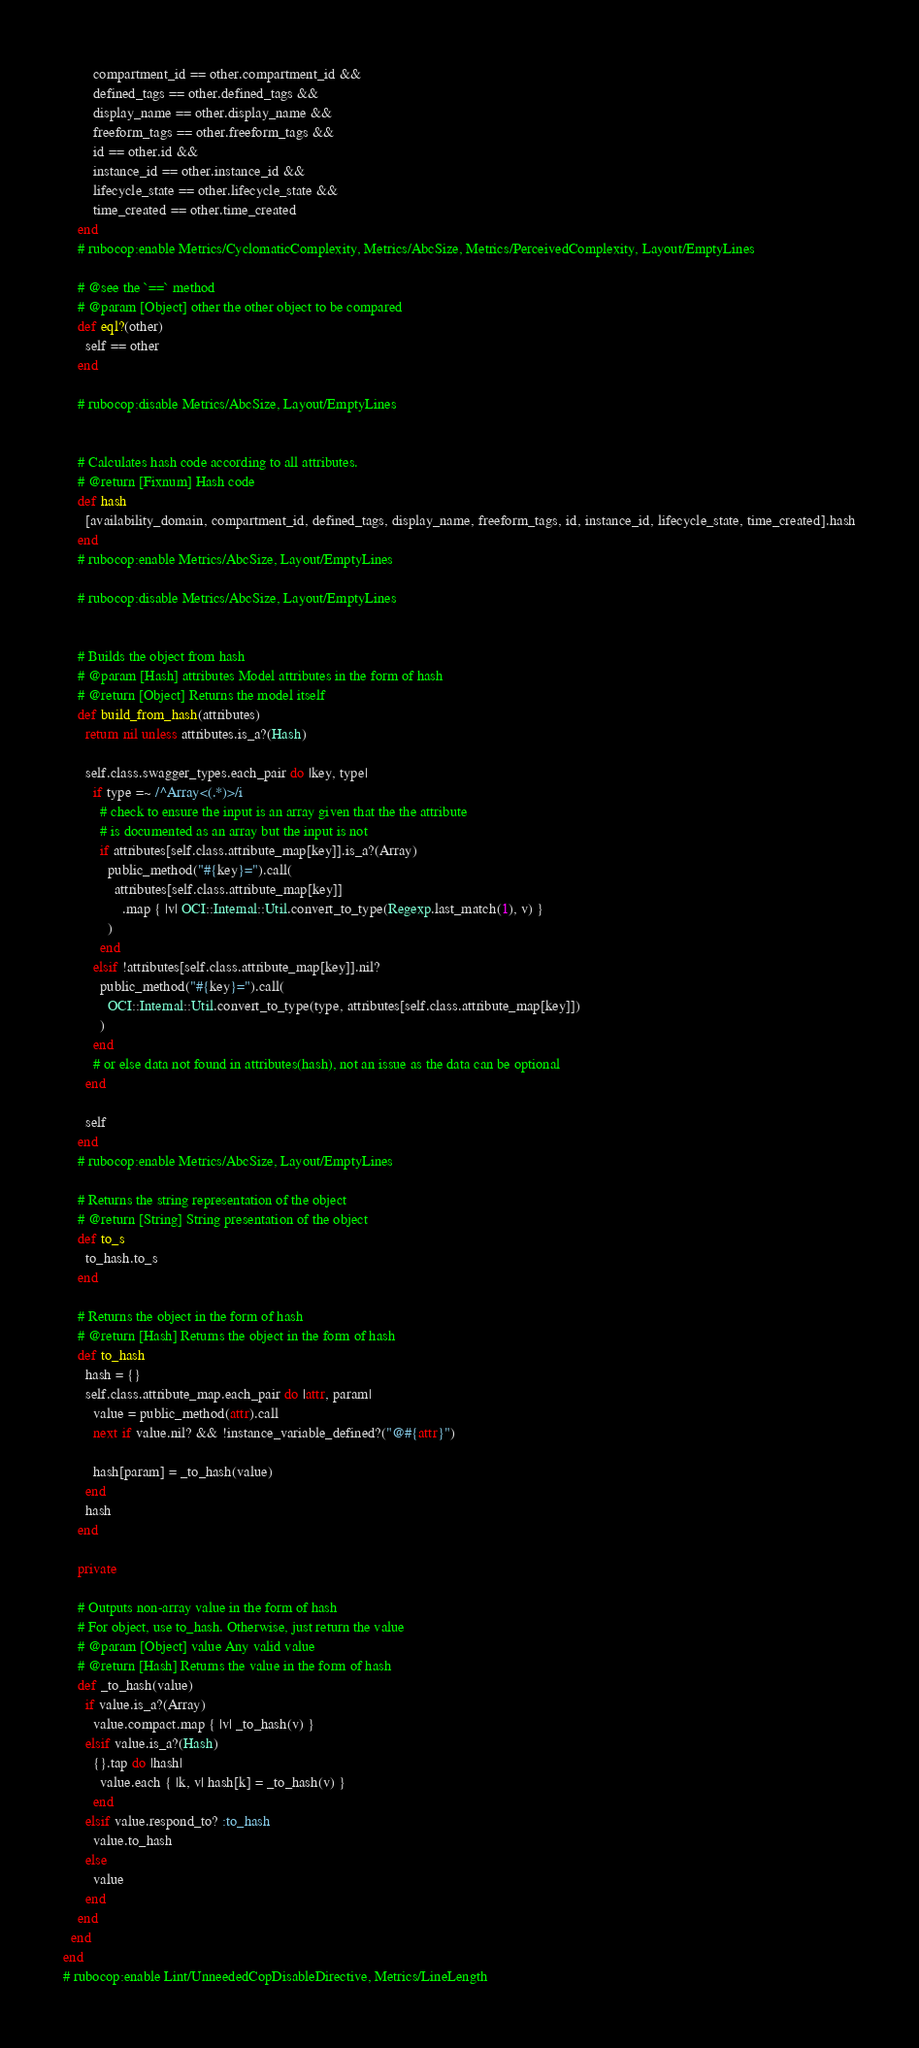<code> <loc_0><loc_0><loc_500><loc_500><_Ruby_>        compartment_id == other.compartment_id &&
        defined_tags == other.defined_tags &&
        display_name == other.display_name &&
        freeform_tags == other.freeform_tags &&
        id == other.id &&
        instance_id == other.instance_id &&
        lifecycle_state == other.lifecycle_state &&
        time_created == other.time_created
    end
    # rubocop:enable Metrics/CyclomaticComplexity, Metrics/AbcSize, Metrics/PerceivedComplexity, Layout/EmptyLines

    # @see the `==` method
    # @param [Object] other the other object to be compared
    def eql?(other)
      self == other
    end

    # rubocop:disable Metrics/AbcSize, Layout/EmptyLines


    # Calculates hash code according to all attributes.
    # @return [Fixnum] Hash code
    def hash
      [availability_domain, compartment_id, defined_tags, display_name, freeform_tags, id, instance_id, lifecycle_state, time_created].hash
    end
    # rubocop:enable Metrics/AbcSize, Layout/EmptyLines

    # rubocop:disable Metrics/AbcSize, Layout/EmptyLines


    # Builds the object from hash
    # @param [Hash] attributes Model attributes in the form of hash
    # @return [Object] Returns the model itself
    def build_from_hash(attributes)
      return nil unless attributes.is_a?(Hash)

      self.class.swagger_types.each_pair do |key, type|
        if type =~ /^Array<(.*)>/i
          # check to ensure the input is an array given that the the attribute
          # is documented as an array but the input is not
          if attributes[self.class.attribute_map[key]].is_a?(Array)
            public_method("#{key}=").call(
              attributes[self.class.attribute_map[key]]
                .map { |v| OCI::Internal::Util.convert_to_type(Regexp.last_match(1), v) }
            )
          end
        elsif !attributes[self.class.attribute_map[key]].nil?
          public_method("#{key}=").call(
            OCI::Internal::Util.convert_to_type(type, attributes[self.class.attribute_map[key]])
          )
        end
        # or else data not found in attributes(hash), not an issue as the data can be optional
      end

      self
    end
    # rubocop:enable Metrics/AbcSize, Layout/EmptyLines

    # Returns the string representation of the object
    # @return [String] String presentation of the object
    def to_s
      to_hash.to_s
    end

    # Returns the object in the form of hash
    # @return [Hash] Returns the object in the form of hash
    def to_hash
      hash = {}
      self.class.attribute_map.each_pair do |attr, param|
        value = public_method(attr).call
        next if value.nil? && !instance_variable_defined?("@#{attr}")

        hash[param] = _to_hash(value)
      end
      hash
    end

    private

    # Outputs non-array value in the form of hash
    # For object, use to_hash. Otherwise, just return the value
    # @param [Object] value Any valid value
    # @return [Hash] Returns the value in the form of hash
    def _to_hash(value)
      if value.is_a?(Array)
        value.compact.map { |v| _to_hash(v) }
      elsif value.is_a?(Hash)
        {}.tap do |hash|
          value.each { |k, v| hash[k] = _to_hash(v) }
        end
      elsif value.respond_to? :to_hash
        value.to_hash
      else
        value
      end
    end
  end
end
# rubocop:enable Lint/UnneededCopDisableDirective, Metrics/LineLength
</code> 